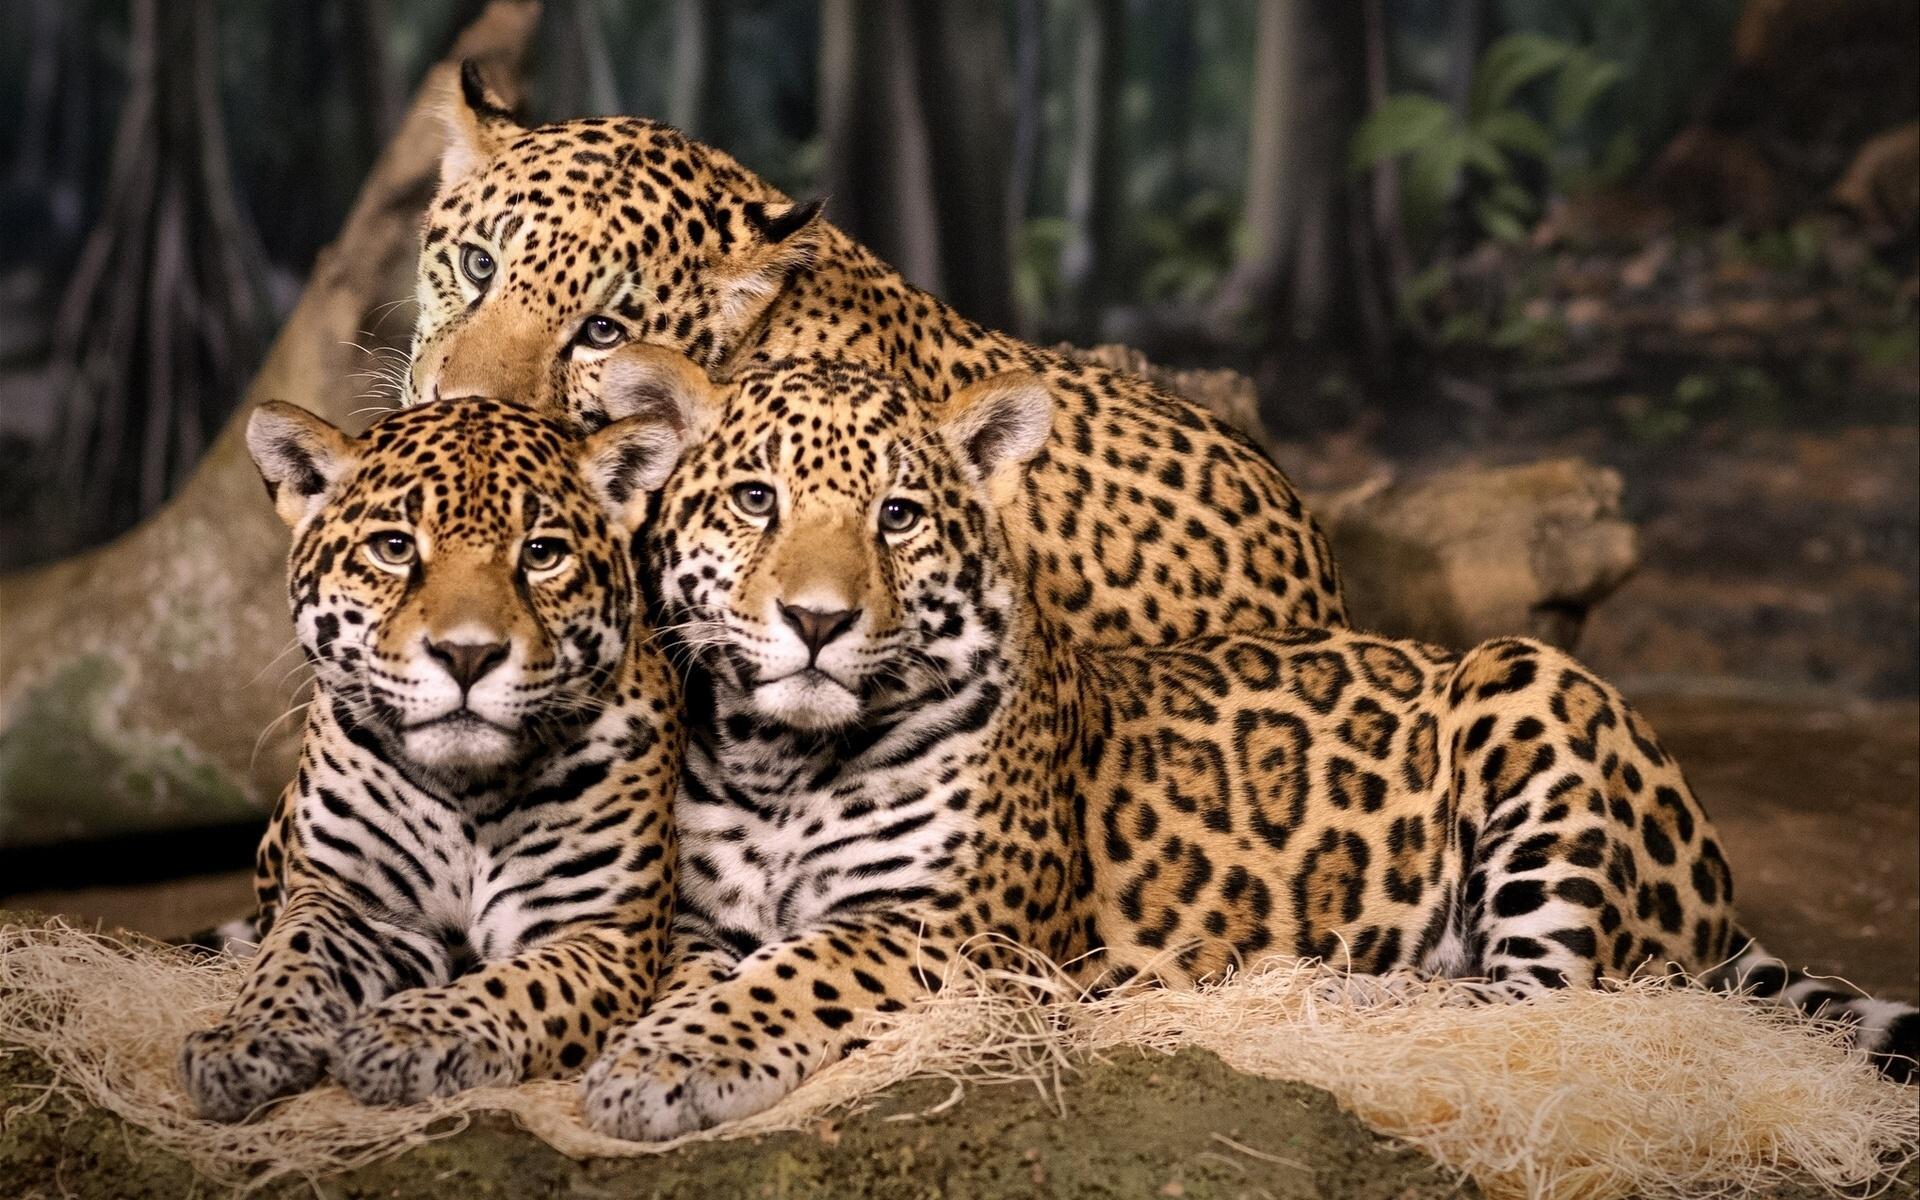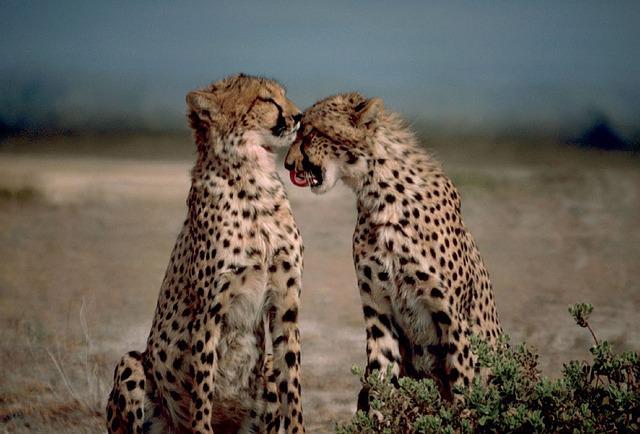The first image is the image on the left, the second image is the image on the right. Considering the images on both sides, is "There are no more than 2 cheetas in the right image." valid? Answer yes or no. Yes. The first image is the image on the left, the second image is the image on the right. Analyze the images presented: Is the assertion "There are no more than two cheetahs in the right image." valid? Answer yes or no. Yes. 